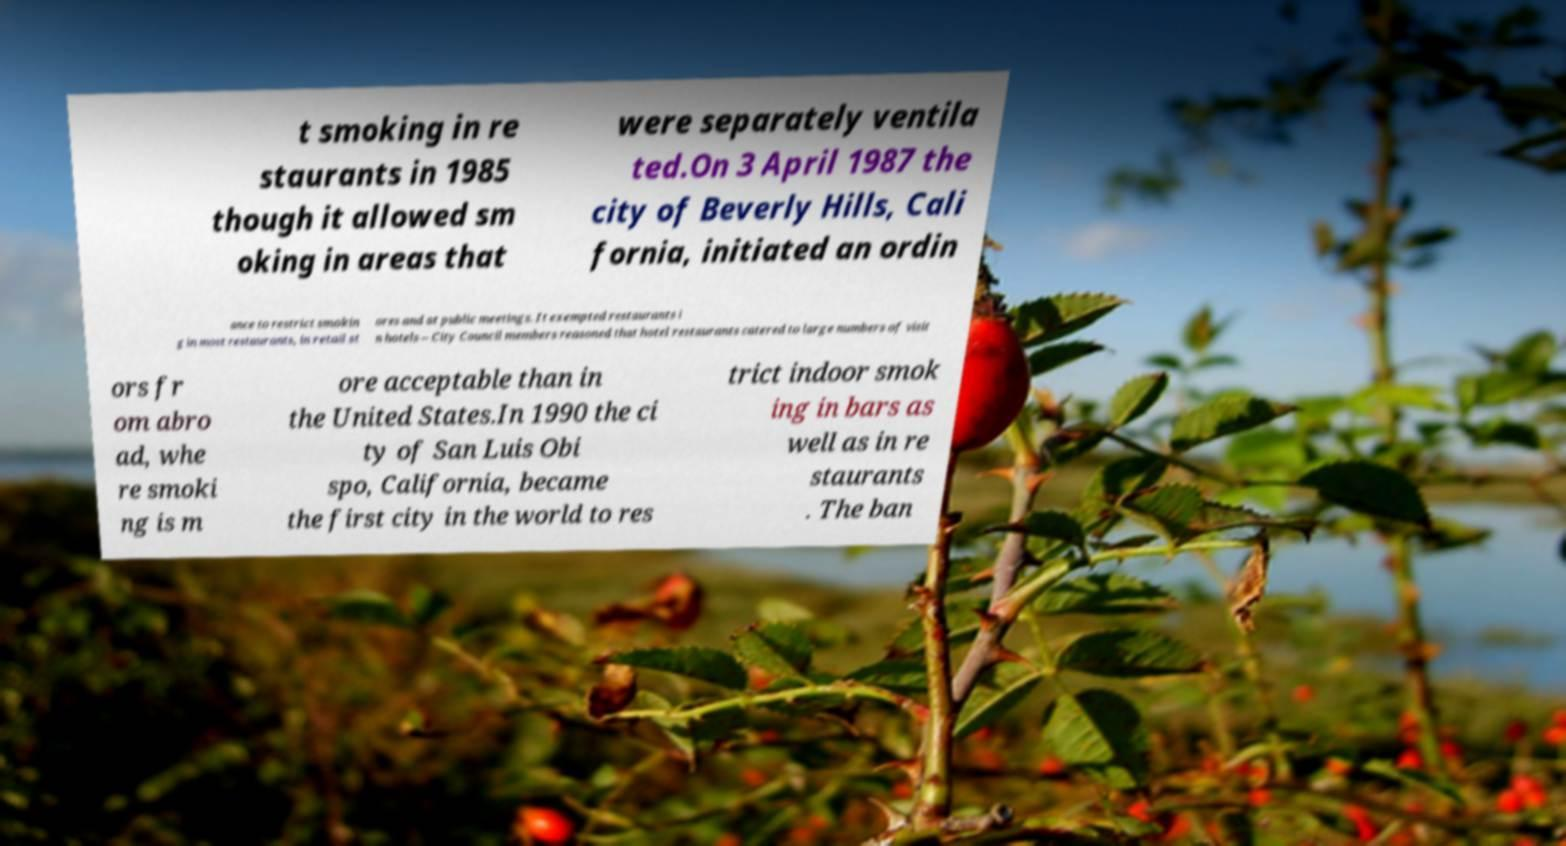Could you assist in decoding the text presented in this image and type it out clearly? t smoking in re staurants in 1985 though it allowed sm oking in areas that were separately ventila ted.On 3 April 1987 the city of Beverly Hills, Cali fornia, initiated an ordin ance to restrict smokin g in most restaurants, in retail st ores and at public meetings. It exempted restaurants i n hotels – City Council members reasoned that hotel restaurants catered to large numbers of visit ors fr om abro ad, whe re smoki ng is m ore acceptable than in the United States.In 1990 the ci ty of San Luis Obi spo, California, became the first city in the world to res trict indoor smok ing in bars as well as in re staurants . The ban 